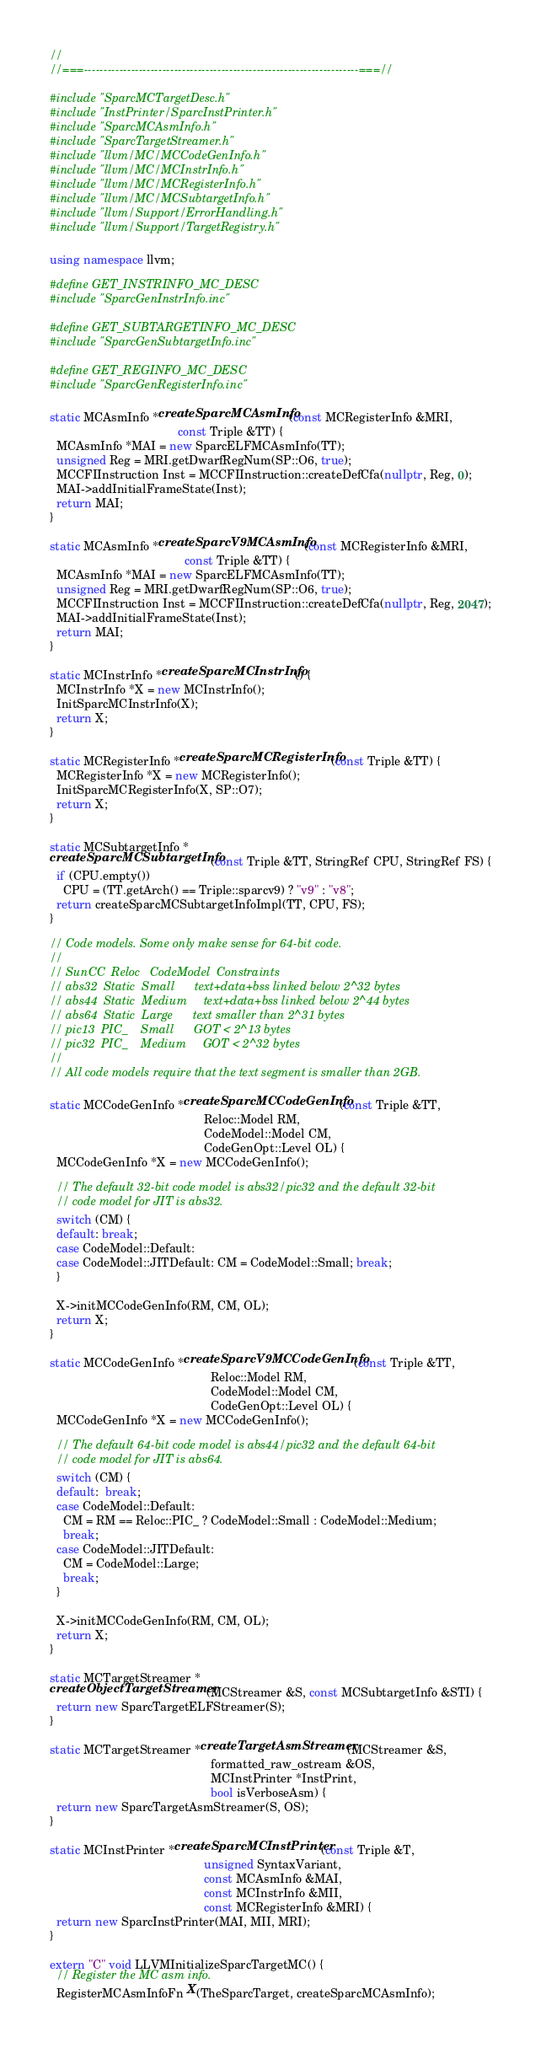<code> <loc_0><loc_0><loc_500><loc_500><_C++_>//
//===----------------------------------------------------------------------===//

#include "SparcMCTargetDesc.h"
#include "InstPrinter/SparcInstPrinter.h"
#include "SparcMCAsmInfo.h"
#include "SparcTargetStreamer.h"
#include "llvm/MC/MCCodeGenInfo.h"
#include "llvm/MC/MCInstrInfo.h"
#include "llvm/MC/MCRegisterInfo.h"
#include "llvm/MC/MCSubtargetInfo.h"
#include "llvm/Support/ErrorHandling.h"
#include "llvm/Support/TargetRegistry.h"

using namespace llvm;

#define GET_INSTRINFO_MC_DESC
#include "SparcGenInstrInfo.inc"

#define GET_SUBTARGETINFO_MC_DESC
#include "SparcGenSubtargetInfo.inc"

#define GET_REGINFO_MC_DESC
#include "SparcGenRegisterInfo.inc"

static MCAsmInfo *createSparcMCAsmInfo(const MCRegisterInfo &MRI,
                                       const Triple &TT) {
  MCAsmInfo *MAI = new SparcELFMCAsmInfo(TT);
  unsigned Reg = MRI.getDwarfRegNum(SP::O6, true);
  MCCFIInstruction Inst = MCCFIInstruction::createDefCfa(nullptr, Reg, 0);
  MAI->addInitialFrameState(Inst);
  return MAI;
}

static MCAsmInfo *createSparcV9MCAsmInfo(const MCRegisterInfo &MRI,
                                         const Triple &TT) {
  MCAsmInfo *MAI = new SparcELFMCAsmInfo(TT);
  unsigned Reg = MRI.getDwarfRegNum(SP::O6, true);
  MCCFIInstruction Inst = MCCFIInstruction::createDefCfa(nullptr, Reg, 2047);
  MAI->addInitialFrameState(Inst);
  return MAI;
}

static MCInstrInfo *createSparcMCInstrInfo() {
  MCInstrInfo *X = new MCInstrInfo();
  InitSparcMCInstrInfo(X);
  return X;
}

static MCRegisterInfo *createSparcMCRegisterInfo(const Triple &TT) {
  MCRegisterInfo *X = new MCRegisterInfo();
  InitSparcMCRegisterInfo(X, SP::O7);
  return X;
}

static MCSubtargetInfo *
createSparcMCSubtargetInfo(const Triple &TT, StringRef CPU, StringRef FS) {
  if (CPU.empty())
    CPU = (TT.getArch() == Triple::sparcv9) ? "v9" : "v8";
  return createSparcMCSubtargetInfoImpl(TT, CPU, FS);
}

// Code models. Some only make sense for 64-bit code.
//
// SunCC  Reloc   CodeModel  Constraints
// abs32  Static  Small      text+data+bss linked below 2^32 bytes
// abs44  Static  Medium     text+data+bss linked below 2^44 bytes
// abs64  Static  Large      text smaller than 2^31 bytes
// pic13  PIC_    Small      GOT < 2^13 bytes
// pic32  PIC_    Medium     GOT < 2^32 bytes
//
// All code models require that the text segment is smaller than 2GB.

static MCCodeGenInfo *createSparcMCCodeGenInfo(const Triple &TT,
                                               Reloc::Model RM,
                                               CodeModel::Model CM,
                                               CodeGenOpt::Level OL) {
  MCCodeGenInfo *X = new MCCodeGenInfo();

  // The default 32-bit code model is abs32/pic32 and the default 32-bit
  // code model for JIT is abs32.
  switch (CM) {
  default: break;
  case CodeModel::Default:
  case CodeModel::JITDefault: CM = CodeModel::Small; break;
  }

  X->initMCCodeGenInfo(RM, CM, OL);
  return X;
}

static MCCodeGenInfo *createSparcV9MCCodeGenInfo(const Triple &TT,
                                                 Reloc::Model RM,
                                                 CodeModel::Model CM,
                                                 CodeGenOpt::Level OL) {
  MCCodeGenInfo *X = new MCCodeGenInfo();

  // The default 64-bit code model is abs44/pic32 and the default 64-bit
  // code model for JIT is abs64.
  switch (CM) {
  default:  break;
  case CodeModel::Default:
    CM = RM == Reloc::PIC_ ? CodeModel::Small : CodeModel::Medium;
    break;
  case CodeModel::JITDefault:
    CM = CodeModel::Large;
    break;
  }

  X->initMCCodeGenInfo(RM, CM, OL);
  return X;
}

static MCTargetStreamer *
createObjectTargetStreamer(MCStreamer &S, const MCSubtargetInfo &STI) {
  return new SparcTargetELFStreamer(S);
}

static MCTargetStreamer *createTargetAsmStreamer(MCStreamer &S,
                                                 formatted_raw_ostream &OS,
                                                 MCInstPrinter *InstPrint,
                                                 bool isVerboseAsm) {
  return new SparcTargetAsmStreamer(S, OS);
}

static MCInstPrinter *createSparcMCInstPrinter(const Triple &T,
                                               unsigned SyntaxVariant,
                                               const MCAsmInfo &MAI,
                                               const MCInstrInfo &MII,
                                               const MCRegisterInfo &MRI) {
  return new SparcInstPrinter(MAI, MII, MRI);
}

extern "C" void LLVMInitializeSparcTargetMC() {
  // Register the MC asm info.
  RegisterMCAsmInfoFn X(TheSparcTarget, createSparcMCAsmInfo);</code> 